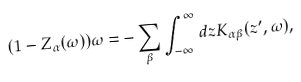<formula> <loc_0><loc_0><loc_500><loc_500>( 1 - Z _ { \alpha } ( \omega ) ) \omega = - \sum _ { \beta } \int _ { - \infty } ^ { \infty } d z K _ { \alpha \beta } ( z ^ { \prime } , \omega ) ,</formula> 